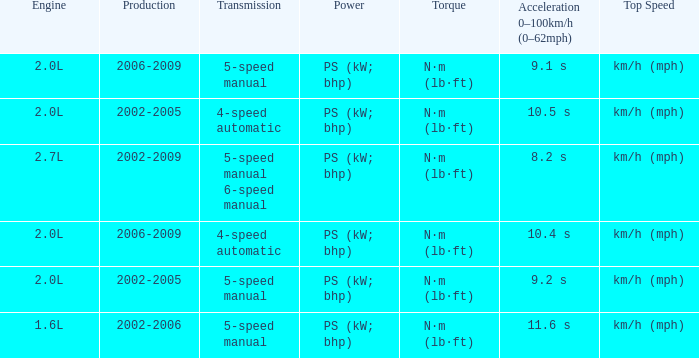What is the top speed of a 5-speed manual transmission produced in 2006-2009? Km/h (mph). 